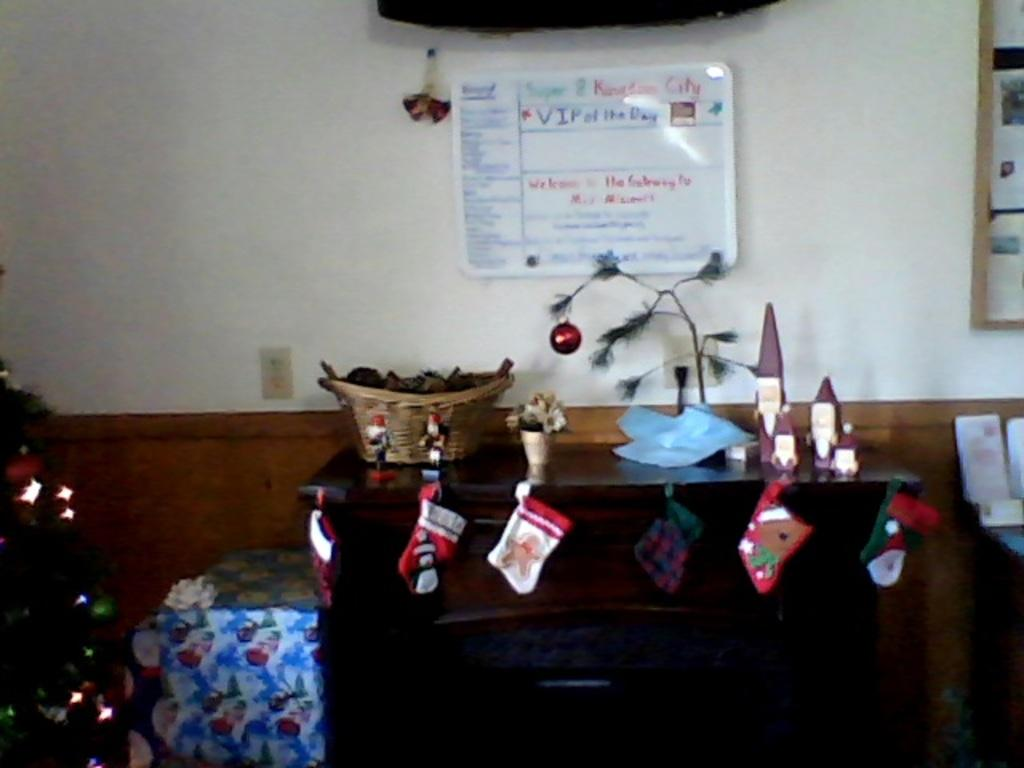What is attached to the wall in the image? There is a banner attached to the wall in the image. What is located in the foreground of the image? There is a table in the foreground of the image. What can be found on the table in the image? There are objects on the table. How many lizards are crawling on the banner in the image? There are no lizards present in the image; it only features a banner attached to the wall. What type of nail is used to attach the banner to the wall in the image? There is no information about the type of nail used to attach the banner to the wall in the image. 